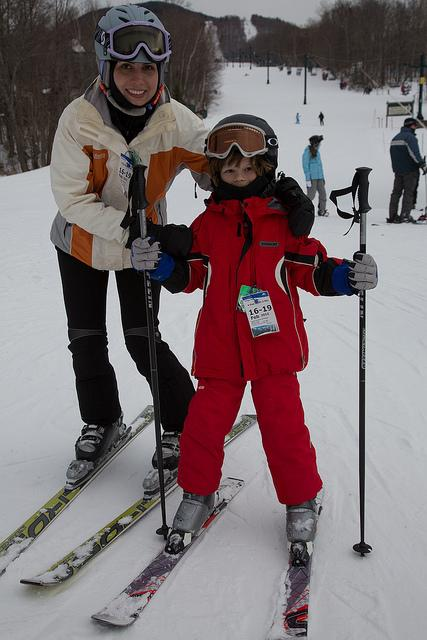What kind of tag hangs from the child in red's jacket? Please explain your reasoning. birth certificate. The people in the picture are skiing. 